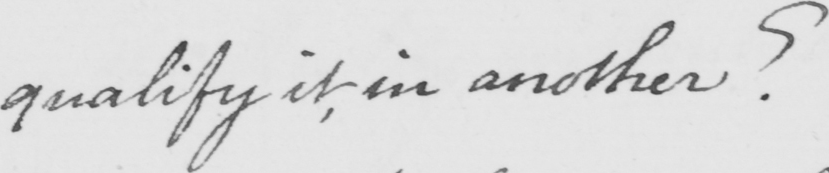Please provide the text content of this handwritten line. qualify it in another ? 